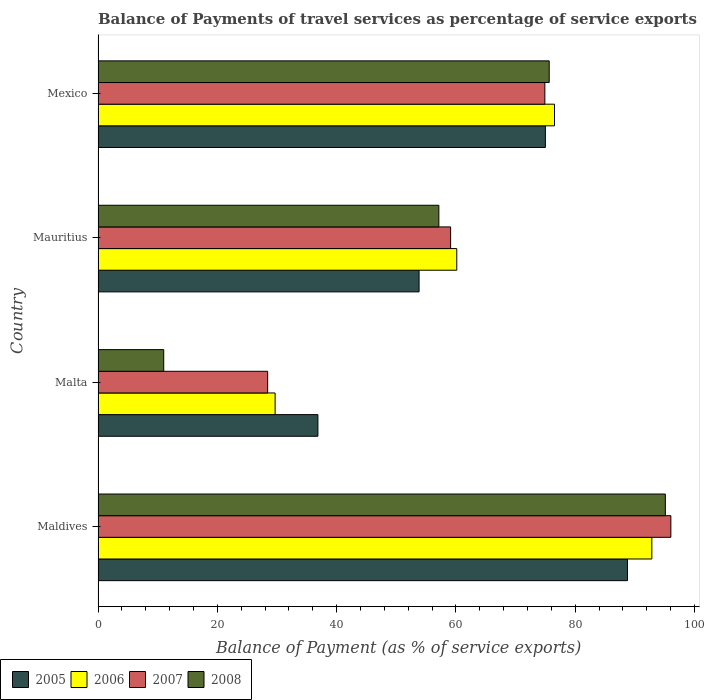How many groups of bars are there?
Keep it short and to the point. 4. Are the number of bars per tick equal to the number of legend labels?
Your answer should be very brief. Yes. How many bars are there on the 3rd tick from the top?
Provide a succinct answer. 4. How many bars are there on the 1st tick from the bottom?
Your answer should be compact. 4. What is the label of the 4th group of bars from the top?
Offer a very short reply. Maldives. What is the balance of payments of travel services in 2006 in Mauritius?
Provide a short and direct response. 60.15. Across all countries, what is the maximum balance of payments of travel services in 2008?
Your answer should be compact. 95.13. Across all countries, what is the minimum balance of payments of travel services in 2006?
Offer a terse response. 29.69. In which country was the balance of payments of travel services in 2006 maximum?
Offer a terse response. Maldives. In which country was the balance of payments of travel services in 2008 minimum?
Ensure brevity in your answer.  Malta. What is the total balance of payments of travel services in 2005 in the graph?
Keep it short and to the point. 254.48. What is the difference between the balance of payments of travel services in 2008 in Maldives and that in Malta?
Keep it short and to the point. 84.11. What is the difference between the balance of payments of travel services in 2005 in Mauritius and the balance of payments of travel services in 2006 in Malta?
Provide a short and direct response. 24.14. What is the average balance of payments of travel services in 2007 per country?
Provide a short and direct response. 64.63. What is the difference between the balance of payments of travel services in 2006 and balance of payments of travel services in 2005 in Mauritius?
Your answer should be very brief. 6.32. What is the ratio of the balance of payments of travel services in 2006 in Malta to that in Mexico?
Provide a succinct answer. 0.39. Is the difference between the balance of payments of travel services in 2006 in Maldives and Malta greater than the difference between the balance of payments of travel services in 2005 in Maldives and Malta?
Provide a succinct answer. Yes. What is the difference between the highest and the second highest balance of payments of travel services in 2007?
Give a very brief answer. 21.13. What is the difference between the highest and the lowest balance of payments of travel services in 2008?
Your answer should be very brief. 84.11. How many bars are there?
Offer a very short reply. 16. Are all the bars in the graph horizontal?
Your response must be concise. Yes. How many countries are there in the graph?
Your answer should be very brief. 4. Does the graph contain any zero values?
Your response must be concise. No. Does the graph contain grids?
Give a very brief answer. No. What is the title of the graph?
Offer a terse response. Balance of Payments of travel services as percentage of service exports. Does "1965" appear as one of the legend labels in the graph?
Give a very brief answer. No. What is the label or title of the X-axis?
Your answer should be very brief. Balance of Payment (as % of service exports). What is the label or title of the Y-axis?
Keep it short and to the point. Country. What is the Balance of Payment (as % of service exports) in 2005 in Maldives?
Your response must be concise. 88.78. What is the Balance of Payment (as % of service exports) of 2006 in Maldives?
Provide a succinct answer. 92.86. What is the Balance of Payment (as % of service exports) of 2007 in Maldives?
Provide a succinct answer. 96.05. What is the Balance of Payment (as % of service exports) of 2008 in Maldives?
Make the answer very short. 95.13. What is the Balance of Payment (as % of service exports) of 2005 in Malta?
Ensure brevity in your answer.  36.87. What is the Balance of Payment (as % of service exports) in 2006 in Malta?
Your answer should be compact. 29.69. What is the Balance of Payment (as % of service exports) of 2007 in Malta?
Provide a short and direct response. 28.44. What is the Balance of Payment (as % of service exports) in 2008 in Malta?
Offer a very short reply. 11.02. What is the Balance of Payment (as % of service exports) of 2005 in Mauritius?
Provide a succinct answer. 53.83. What is the Balance of Payment (as % of service exports) of 2006 in Mauritius?
Give a very brief answer. 60.15. What is the Balance of Payment (as % of service exports) of 2007 in Mauritius?
Ensure brevity in your answer.  59.12. What is the Balance of Payment (as % of service exports) of 2008 in Mauritius?
Your answer should be compact. 57.15. What is the Balance of Payment (as % of service exports) in 2005 in Mexico?
Keep it short and to the point. 75.01. What is the Balance of Payment (as % of service exports) in 2006 in Mexico?
Keep it short and to the point. 76.54. What is the Balance of Payment (as % of service exports) in 2007 in Mexico?
Ensure brevity in your answer.  74.92. What is the Balance of Payment (as % of service exports) in 2008 in Mexico?
Make the answer very short. 75.65. Across all countries, what is the maximum Balance of Payment (as % of service exports) of 2005?
Offer a very short reply. 88.78. Across all countries, what is the maximum Balance of Payment (as % of service exports) in 2006?
Offer a terse response. 92.86. Across all countries, what is the maximum Balance of Payment (as % of service exports) of 2007?
Ensure brevity in your answer.  96.05. Across all countries, what is the maximum Balance of Payment (as % of service exports) of 2008?
Offer a terse response. 95.13. Across all countries, what is the minimum Balance of Payment (as % of service exports) in 2005?
Offer a very short reply. 36.87. Across all countries, what is the minimum Balance of Payment (as % of service exports) of 2006?
Your answer should be compact. 29.69. Across all countries, what is the minimum Balance of Payment (as % of service exports) in 2007?
Ensure brevity in your answer.  28.44. Across all countries, what is the minimum Balance of Payment (as % of service exports) in 2008?
Your answer should be very brief. 11.02. What is the total Balance of Payment (as % of service exports) in 2005 in the graph?
Your response must be concise. 254.48. What is the total Balance of Payment (as % of service exports) in 2006 in the graph?
Keep it short and to the point. 259.24. What is the total Balance of Payment (as % of service exports) of 2007 in the graph?
Keep it short and to the point. 258.53. What is the total Balance of Payment (as % of service exports) of 2008 in the graph?
Ensure brevity in your answer.  238.94. What is the difference between the Balance of Payment (as % of service exports) in 2005 in Maldives and that in Malta?
Offer a very short reply. 51.91. What is the difference between the Balance of Payment (as % of service exports) in 2006 in Maldives and that in Malta?
Keep it short and to the point. 63.17. What is the difference between the Balance of Payment (as % of service exports) of 2007 in Maldives and that in Malta?
Your answer should be very brief. 67.61. What is the difference between the Balance of Payment (as % of service exports) in 2008 in Maldives and that in Malta?
Provide a short and direct response. 84.11. What is the difference between the Balance of Payment (as % of service exports) of 2005 in Maldives and that in Mauritius?
Your answer should be compact. 34.95. What is the difference between the Balance of Payment (as % of service exports) in 2006 in Maldives and that in Mauritius?
Your answer should be compact. 32.71. What is the difference between the Balance of Payment (as % of service exports) of 2007 in Maldives and that in Mauritius?
Your answer should be compact. 36.93. What is the difference between the Balance of Payment (as % of service exports) of 2008 in Maldives and that in Mauritius?
Offer a terse response. 37.98. What is the difference between the Balance of Payment (as % of service exports) of 2005 in Maldives and that in Mexico?
Provide a short and direct response. 13.77. What is the difference between the Balance of Payment (as % of service exports) of 2006 in Maldives and that in Mexico?
Your response must be concise. 16.32. What is the difference between the Balance of Payment (as % of service exports) of 2007 in Maldives and that in Mexico?
Provide a short and direct response. 21.13. What is the difference between the Balance of Payment (as % of service exports) of 2008 in Maldives and that in Mexico?
Offer a terse response. 19.47. What is the difference between the Balance of Payment (as % of service exports) of 2005 in Malta and that in Mauritius?
Make the answer very short. -16.96. What is the difference between the Balance of Payment (as % of service exports) of 2006 in Malta and that in Mauritius?
Offer a very short reply. -30.46. What is the difference between the Balance of Payment (as % of service exports) in 2007 in Malta and that in Mauritius?
Keep it short and to the point. -30.68. What is the difference between the Balance of Payment (as % of service exports) in 2008 in Malta and that in Mauritius?
Your response must be concise. -46.13. What is the difference between the Balance of Payment (as % of service exports) in 2005 in Malta and that in Mexico?
Provide a succinct answer. -38.14. What is the difference between the Balance of Payment (as % of service exports) in 2006 in Malta and that in Mexico?
Offer a terse response. -46.85. What is the difference between the Balance of Payment (as % of service exports) in 2007 in Malta and that in Mexico?
Your answer should be very brief. -46.48. What is the difference between the Balance of Payment (as % of service exports) in 2008 in Malta and that in Mexico?
Your answer should be very brief. -64.64. What is the difference between the Balance of Payment (as % of service exports) in 2005 in Mauritius and that in Mexico?
Make the answer very short. -21.18. What is the difference between the Balance of Payment (as % of service exports) of 2006 in Mauritius and that in Mexico?
Make the answer very short. -16.39. What is the difference between the Balance of Payment (as % of service exports) of 2007 in Mauritius and that in Mexico?
Keep it short and to the point. -15.8. What is the difference between the Balance of Payment (as % of service exports) in 2008 in Mauritius and that in Mexico?
Offer a terse response. -18.5. What is the difference between the Balance of Payment (as % of service exports) of 2005 in Maldives and the Balance of Payment (as % of service exports) of 2006 in Malta?
Make the answer very short. 59.09. What is the difference between the Balance of Payment (as % of service exports) in 2005 in Maldives and the Balance of Payment (as % of service exports) in 2007 in Malta?
Your answer should be compact. 60.34. What is the difference between the Balance of Payment (as % of service exports) of 2005 in Maldives and the Balance of Payment (as % of service exports) of 2008 in Malta?
Offer a terse response. 77.76. What is the difference between the Balance of Payment (as % of service exports) in 2006 in Maldives and the Balance of Payment (as % of service exports) in 2007 in Malta?
Your response must be concise. 64.42. What is the difference between the Balance of Payment (as % of service exports) of 2006 in Maldives and the Balance of Payment (as % of service exports) of 2008 in Malta?
Make the answer very short. 81.84. What is the difference between the Balance of Payment (as % of service exports) of 2007 in Maldives and the Balance of Payment (as % of service exports) of 2008 in Malta?
Offer a very short reply. 85.03. What is the difference between the Balance of Payment (as % of service exports) of 2005 in Maldives and the Balance of Payment (as % of service exports) of 2006 in Mauritius?
Make the answer very short. 28.63. What is the difference between the Balance of Payment (as % of service exports) in 2005 in Maldives and the Balance of Payment (as % of service exports) in 2007 in Mauritius?
Your response must be concise. 29.66. What is the difference between the Balance of Payment (as % of service exports) in 2005 in Maldives and the Balance of Payment (as % of service exports) in 2008 in Mauritius?
Keep it short and to the point. 31.63. What is the difference between the Balance of Payment (as % of service exports) in 2006 in Maldives and the Balance of Payment (as % of service exports) in 2007 in Mauritius?
Give a very brief answer. 33.74. What is the difference between the Balance of Payment (as % of service exports) of 2006 in Maldives and the Balance of Payment (as % of service exports) of 2008 in Mauritius?
Provide a short and direct response. 35.71. What is the difference between the Balance of Payment (as % of service exports) in 2007 in Maldives and the Balance of Payment (as % of service exports) in 2008 in Mauritius?
Offer a terse response. 38.9. What is the difference between the Balance of Payment (as % of service exports) in 2005 in Maldives and the Balance of Payment (as % of service exports) in 2006 in Mexico?
Give a very brief answer. 12.24. What is the difference between the Balance of Payment (as % of service exports) of 2005 in Maldives and the Balance of Payment (as % of service exports) of 2007 in Mexico?
Provide a short and direct response. 13.86. What is the difference between the Balance of Payment (as % of service exports) of 2005 in Maldives and the Balance of Payment (as % of service exports) of 2008 in Mexico?
Give a very brief answer. 13.12. What is the difference between the Balance of Payment (as % of service exports) in 2006 in Maldives and the Balance of Payment (as % of service exports) in 2007 in Mexico?
Your answer should be very brief. 17.94. What is the difference between the Balance of Payment (as % of service exports) of 2006 in Maldives and the Balance of Payment (as % of service exports) of 2008 in Mexico?
Provide a succinct answer. 17.21. What is the difference between the Balance of Payment (as % of service exports) of 2007 in Maldives and the Balance of Payment (as % of service exports) of 2008 in Mexico?
Provide a succinct answer. 20.4. What is the difference between the Balance of Payment (as % of service exports) in 2005 in Malta and the Balance of Payment (as % of service exports) in 2006 in Mauritius?
Offer a terse response. -23.28. What is the difference between the Balance of Payment (as % of service exports) in 2005 in Malta and the Balance of Payment (as % of service exports) in 2007 in Mauritius?
Offer a very short reply. -22.25. What is the difference between the Balance of Payment (as % of service exports) in 2005 in Malta and the Balance of Payment (as % of service exports) in 2008 in Mauritius?
Your answer should be very brief. -20.28. What is the difference between the Balance of Payment (as % of service exports) of 2006 in Malta and the Balance of Payment (as % of service exports) of 2007 in Mauritius?
Offer a terse response. -29.43. What is the difference between the Balance of Payment (as % of service exports) of 2006 in Malta and the Balance of Payment (as % of service exports) of 2008 in Mauritius?
Keep it short and to the point. -27.46. What is the difference between the Balance of Payment (as % of service exports) in 2007 in Malta and the Balance of Payment (as % of service exports) in 2008 in Mauritius?
Offer a very short reply. -28.71. What is the difference between the Balance of Payment (as % of service exports) in 2005 in Malta and the Balance of Payment (as % of service exports) in 2006 in Mexico?
Offer a terse response. -39.67. What is the difference between the Balance of Payment (as % of service exports) of 2005 in Malta and the Balance of Payment (as % of service exports) of 2007 in Mexico?
Your answer should be compact. -38.05. What is the difference between the Balance of Payment (as % of service exports) in 2005 in Malta and the Balance of Payment (as % of service exports) in 2008 in Mexico?
Your response must be concise. -38.78. What is the difference between the Balance of Payment (as % of service exports) of 2006 in Malta and the Balance of Payment (as % of service exports) of 2007 in Mexico?
Ensure brevity in your answer.  -45.23. What is the difference between the Balance of Payment (as % of service exports) of 2006 in Malta and the Balance of Payment (as % of service exports) of 2008 in Mexico?
Ensure brevity in your answer.  -45.96. What is the difference between the Balance of Payment (as % of service exports) in 2007 in Malta and the Balance of Payment (as % of service exports) in 2008 in Mexico?
Provide a succinct answer. -47.21. What is the difference between the Balance of Payment (as % of service exports) of 2005 in Mauritius and the Balance of Payment (as % of service exports) of 2006 in Mexico?
Ensure brevity in your answer.  -22.71. What is the difference between the Balance of Payment (as % of service exports) of 2005 in Mauritius and the Balance of Payment (as % of service exports) of 2007 in Mexico?
Your answer should be compact. -21.09. What is the difference between the Balance of Payment (as % of service exports) of 2005 in Mauritius and the Balance of Payment (as % of service exports) of 2008 in Mexico?
Your answer should be very brief. -21.82. What is the difference between the Balance of Payment (as % of service exports) of 2006 in Mauritius and the Balance of Payment (as % of service exports) of 2007 in Mexico?
Provide a succinct answer. -14.77. What is the difference between the Balance of Payment (as % of service exports) in 2006 in Mauritius and the Balance of Payment (as % of service exports) in 2008 in Mexico?
Provide a short and direct response. -15.5. What is the difference between the Balance of Payment (as % of service exports) of 2007 in Mauritius and the Balance of Payment (as % of service exports) of 2008 in Mexico?
Your answer should be very brief. -16.53. What is the average Balance of Payment (as % of service exports) in 2005 per country?
Give a very brief answer. 63.62. What is the average Balance of Payment (as % of service exports) in 2006 per country?
Offer a very short reply. 64.81. What is the average Balance of Payment (as % of service exports) in 2007 per country?
Provide a succinct answer. 64.63. What is the average Balance of Payment (as % of service exports) in 2008 per country?
Ensure brevity in your answer.  59.73. What is the difference between the Balance of Payment (as % of service exports) of 2005 and Balance of Payment (as % of service exports) of 2006 in Maldives?
Offer a very short reply. -4.08. What is the difference between the Balance of Payment (as % of service exports) in 2005 and Balance of Payment (as % of service exports) in 2007 in Maldives?
Your answer should be very brief. -7.27. What is the difference between the Balance of Payment (as % of service exports) in 2005 and Balance of Payment (as % of service exports) in 2008 in Maldives?
Provide a succinct answer. -6.35. What is the difference between the Balance of Payment (as % of service exports) in 2006 and Balance of Payment (as % of service exports) in 2007 in Maldives?
Provide a succinct answer. -3.19. What is the difference between the Balance of Payment (as % of service exports) of 2006 and Balance of Payment (as % of service exports) of 2008 in Maldives?
Provide a short and direct response. -2.27. What is the difference between the Balance of Payment (as % of service exports) in 2007 and Balance of Payment (as % of service exports) in 2008 in Maldives?
Offer a terse response. 0.92. What is the difference between the Balance of Payment (as % of service exports) of 2005 and Balance of Payment (as % of service exports) of 2006 in Malta?
Ensure brevity in your answer.  7.18. What is the difference between the Balance of Payment (as % of service exports) in 2005 and Balance of Payment (as % of service exports) in 2007 in Malta?
Offer a terse response. 8.43. What is the difference between the Balance of Payment (as % of service exports) of 2005 and Balance of Payment (as % of service exports) of 2008 in Malta?
Your answer should be compact. 25.85. What is the difference between the Balance of Payment (as % of service exports) in 2006 and Balance of Payment (as % of service exports) in 2007 in Malta?
Your answer should be compact. 1.25. What is the difference between the Balance of Payment (as % of service exports) of 2006 and Balance of Payment (as % of service exports) of 2008 in Malta?
Your response must be concise. 18.67. What is the difference between the Balance of Payment (as % of service exports) in 2007 and Balance of Payment (as % of service exports) in 2008 in Malta?
Offer a very short reply. 17.43. What is the difference between the Balance of Payment (as % of service exports) in 2005 and Balance of Payment (as % of service exports) in 2006 in Mauritius?
Keep it short and to the point. -6.32. What is the difference between the Balance of Payment (as % of service exports) of 2005 and Balance of Payment (as % of service exports) of 2007 in Mauritius?
Your response must be concise. -5.29. What is the difference between the Balance of Payment (as % of service exports) of 2005 and Balance of Payment (as % of service exports) of 2008 in Mauritius?
Your answer should be very brief. -3.32. What is the difference between the Balance of Payment (as % of service exports) in 2006 and Balance of Payment (as % of service exports) in 2007 in Mauritius?
Keep it short and to the point. 1.03. What is the difference between the Balance of Payment (as % of service exports) in 2006 and Balance of Payment (as % of service exports) in 2008 in Mauritius?
Your response must be concise. 3. What is the difference between the Balance of Payment (as % of service exports) of 2007 and Balance of Payment (as % of service exports) of 2008 in Mauritius?
Your answer should be compact. 1.97. What is the difference between the Balance of Payment (as % of service exports) of 2005 and Balance of Payment (as % of service exports) of 2006 in Mexico?
Keep it short and to the point. -1.53. What is the difference between the Balance of Payment (as % of service exports) of 2005 and Balance of Payment (as % of service exports) of 2007 in Mexico?
Provide a short and direct response. 0.09. What is the difference between the Balance of Payment (as % of service exports) of 2005 and Balance of Payment (as % of service exports) of 2008 in Mexico?
Provide a short and direct response. -0.64. What is the difference between the Balance of Payment (as % of service exports) in 2006 and Balance of Payment (as % of service exports) in 2007 in Mexico?
Your answer should be very brief. 1.62. What is the difference between the Balance of Payment (as % of service exports) in 2006 and Balance of Payment (as % of service exports) in 2008 in Mexico?
Your answer should be compact. 0.89. What is the difference between the Balance of Payment (as % of service exports) of 2007 and Balance of Payment (as % of service exports) of 2008 in Mexico?
Make the answer very short. -0.73. What is the ratio of the Balance of Payment (as % of service exports) of 2005 in Maldives to that in Malta?
Your answer should be compact. 2.41. What is the ratio of the Balance of Payment (as % of service exports) of 2006 in Maldives to that in Malta?
Provide a succinct answer. 3.13. What is the ratio of the Balance of Payment (as % of service exports) of 2007 in Maldives to that in Malta?
Your answer should be very brief. 3.38. What is the ratio of the Balance of Payment (as % of service exports) of 2008 in Maldives to that in Malta?
Provide a short and direct response. 8.64. What is the ratio of the Balance of Payment (as % of service exports) of 2005 in Maldives to that in Mauritius?
Offer a very short reply. 1.65. What is the ratio of the Balance of Payment (as % of service exports) in 2006 in Maldives to that in Mauritius?
Ensure brevity in your answer.  1.54. What is the ratio of the Balance of Payment (as % of service exports) in 2007 in Maldives to that in Mauritius?
Make the answer very short. 1.62. What is the ratio of the Balance of Payment (as % of service exports) in 2008 in Maldives to that in Mauritius?
Make the answer very short. 1.66. What is the ratio of the Balance of Payment (as % of service exports) of 2005 in Maldives to that in Mexico?
Provide a succinct answer. 1.18. What is the ratio of the Balance of Payment (as % of service exports) in 2006 in Maldives to that in Mexico?
Offer a terse response. 1.21. What is the ratio of the Balance of Payment (as % of service exports) in 2007 in Maldives to that in Mexico?
Keep it short and to the point. 1.28. What is the ratio of the Balance of Payment (as % of service exports) of 2008 in Maldives to that in Mexico?
Offer a terse response. 1.26. What is the ratio of the Balance of Payment (as % of service exports) in 2005 in Malta to that in Mauritius?
Your answer should be very brief. 0.68. What is the ratio of the Balance of Payment (as % of service exports) of 2006 in Malta to that in Mauritius?
Provide a succinct answer. 0.49. What is the ratio of the Balance of Payment (as % of service exports) of 2007 in Malta to that in Mauritius?
Keep it short and to the point. 0.48. What is the ratio of the Balance of Payment (as % of service exports) in 2008 in Malta to that in Mauritius?
Provide a succinct answer. 0.19. What is the ratio of the Balance of Payment (as % of service exports) of 2005 in Malta to that in Mexico?
Keep it short and to the point. 0.49. What is the ratio of the Balance of Payment (as % of service exports) of 2006 in Malta to that in Mexico?
Keep it short and to the point. 0.39. What is the ratio of the Balance of Payment (as % of service exports) in 2007 in Malta to that in Mexico?
Offer a terse response. 0.38. What is the ratio of the Balance of Payment (as % of service exports) in 2008 in Malta to that in Mexico?
Your answer should be very brief. 0.15. What is the ratio of the Balance of Payment (as % of service exports) of 2005 in Mauritius to that in Mexico?
Your answer should be very brief. 0.72. What is the ratio of the Balance of Payment (as % of service exports) of 2006 in Mauritius to that in Mexico?
Offer a very short reply. 0.79. What is the ratio of the Balance of Payment (as % of service exports) in 2007 in Mauritius to that in Mexico?
Your answer should be compact. 0.79. What is the ratio of the Balance of Payment (as % of service exports) in 2008 in Mauritius to that in Mexico?
Provide a succinct answer. 0.76. What is the difference between the highest and the second highest Balance of Payment (as % of service exports) of 2005?
Provide a succinct answer. 13.77. What is the difference between the highest and the second highest Balance of Payment (as % of service exports) in 2006?
Your answer should be very brief. 16.32. What is the difference between the highest and the second highest Balance of Payment (as % of service exports) of 2007?
Provide a short and direct response. 21.13. What is the difference between the highest and the second highest Balance of Payment (as % of service exports) in 2008?
Provide a short and direct response. 19.47. What is the difference between the highest and the lowest Balance of Payment (as % of service exports) in 2005?
Provide a short and direct response. 51.91. What is the difference between the highest and the lowest Balance of Payment (as % of service exports) in 2006?
Your answer should be compact. 63.17. What is the difference between the highest and the lowest Balance of Payment (as % of service exports) in 2007?
Keep it short and to the point. 67.61. What is the difference between the highest and the lowest Balance of Payment (as % of service exports) in 2008?
Your response must be concise. 84.11. 